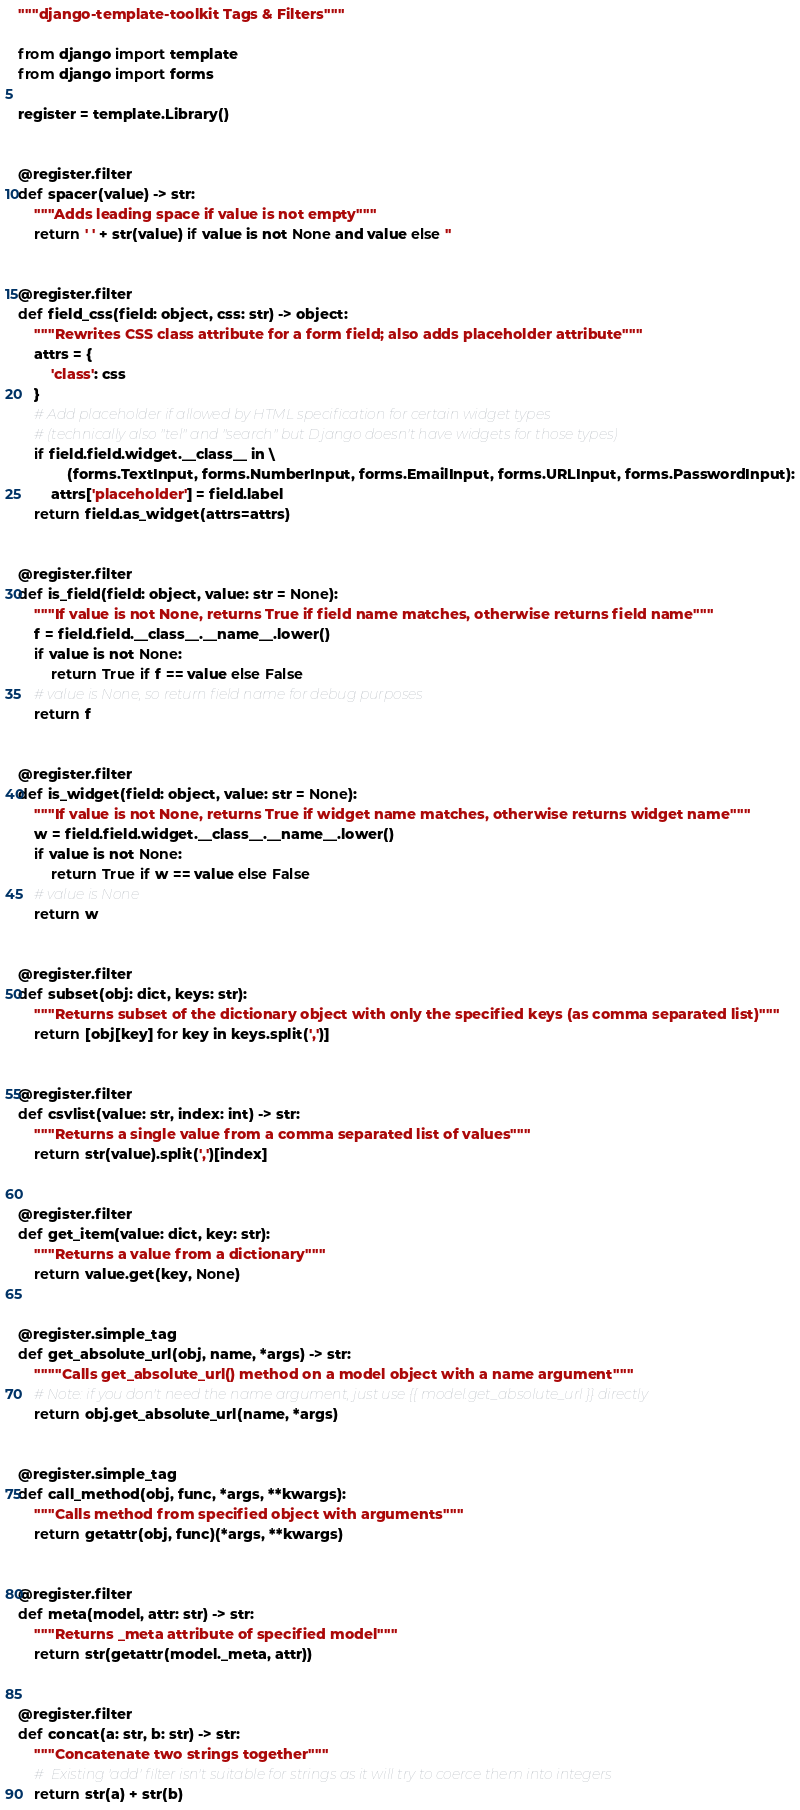Convert code to text. <code><loc_0><loc_0><loc_500><loc_500><_Python_>"""django-template-toolkit Tags & Filters"""

from django import template
from django import forms

register = template.Library()


@register.filter
def spacer(value) -> str:
    """Adds leading space if value is not empty"""
    return ' ' + str(value) if value is not None and value else ''


@register.filter
def field_css(field: object, css: str) -> object:
    """Rewrites CSS class attribute for a form field; also adds placeholder attribute"""
    attrs = {
        'class': css
    }
    # Add placeholder if allowed by HTML specification for certain widget types
    # (technically also "tel" and "search" but Django doesn't have widgets for those types)
    if field.field.widget.__class__ in \
            (forms.TextInput, forms.NumberInput, forms.EmailInput, forms.URLInput, forms.PasswordInput):
        attrs['placeholder'] = field.label
    return field.as_widget(attrs=attrs)


@register.filter
def is_field(field: object, value: str = None):
    """If value is not None, returns True if field name matches, otherwise returns field name"""
    f = field.field.__class__.__name__.lower()
    if value is not None:
        return True if f == value else False
    # value is None, so return field name for debug purposes
    return f


@register.filter
def is_widget(field: object, value: str = None):
    """If value is not None, returns True if widget name matches, otherwise returns widget name"""
    w = field.field.widget.__class__.__name__.lower()
    if value is not None:
        return True if w == value else False
    # value is None
    return w


@register.filter
def subset(obj: dict, keys: str):
    """Returns subset of the dictionary object with only the specified keys (as comma separated list)"""
    return [obj[key] for key in keys.split(',')]


@register.filter
def csvlist(value: str, index: int) -> str:
    """Returns a single value from a comma separated list of values"""
    return str(value).split(',')[index]


@register.filter
def get_item(value: dict, key: str):
    """Returns a value from a dictionary"""
    return value.get(key, None)


@register.simple_tag
def get_absolute_url(obj, name, *args) -> str:
    """"Calls get_absolute_url() method on a model object with a name argument"""
    # Note: if you don't need the name argument, just use {{ model.get_absolute_url }} directly
    return obj.get_absolute_url(name, *args)


@register.simple_tag
def call_method(obj, func, *args, **kwargs):
    """Calls method from specified object with arguments"""
    return getattr(obj, func)(*args, **kwargs)


@register.filter
def meta(model, attr: str) -> str:
    """Returns _meta attribute of specified model"""
    return str(getattr(model._meta, attr))


@register.filter
def concat(a: str, b: str) -> str:
    """Concatenate two strings together"""
    #  Existing 'add' filter isn't suitable for strings as it will try to coerce them into integers
    return str(a) + str(b)
</code> 